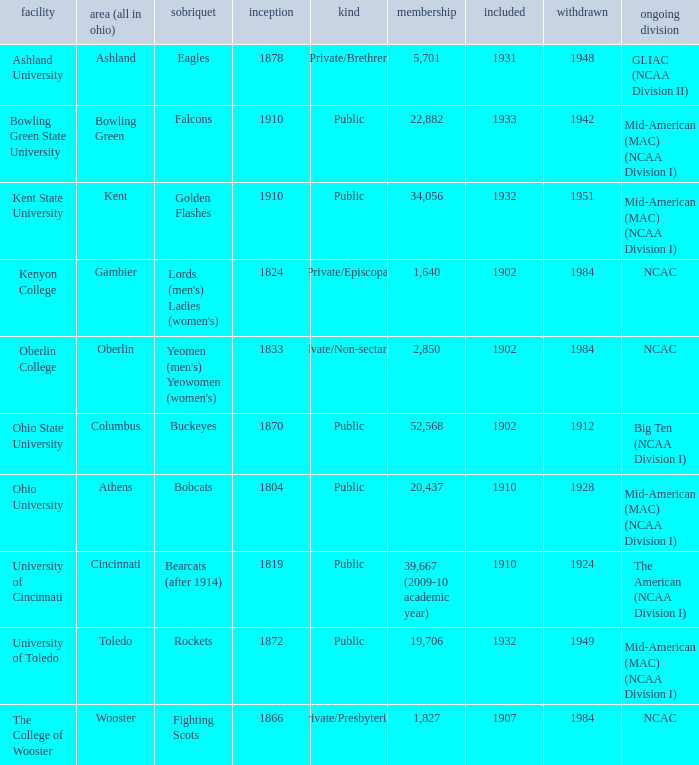What is the enrollment for Ashland University? 5701.0. 